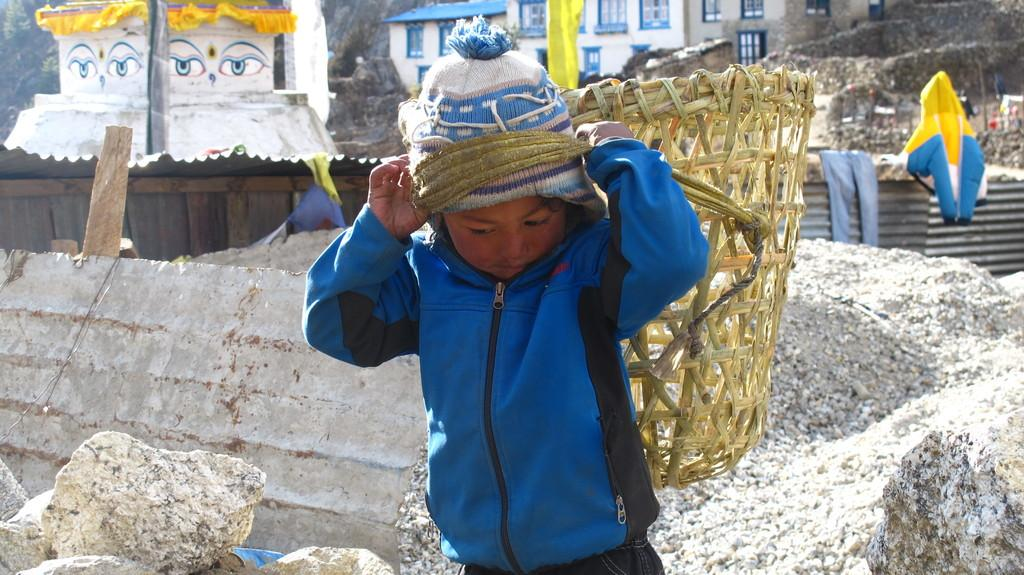What is the main subject of the image? The main subject of the image is a child. What is the child doing in the image? The child is carrying a basket on his back. What can be seen on the left side of the image? There are many rocks on the left side of the image. What is visible in the background of the image? There is a house visible in the background of the image. Where is the hydrant located in the image? There is no hydrant present in the image. What type of meeting is taking place in the image? There is no meeting depicted in the image; it features a child carrying a basket on his back. 